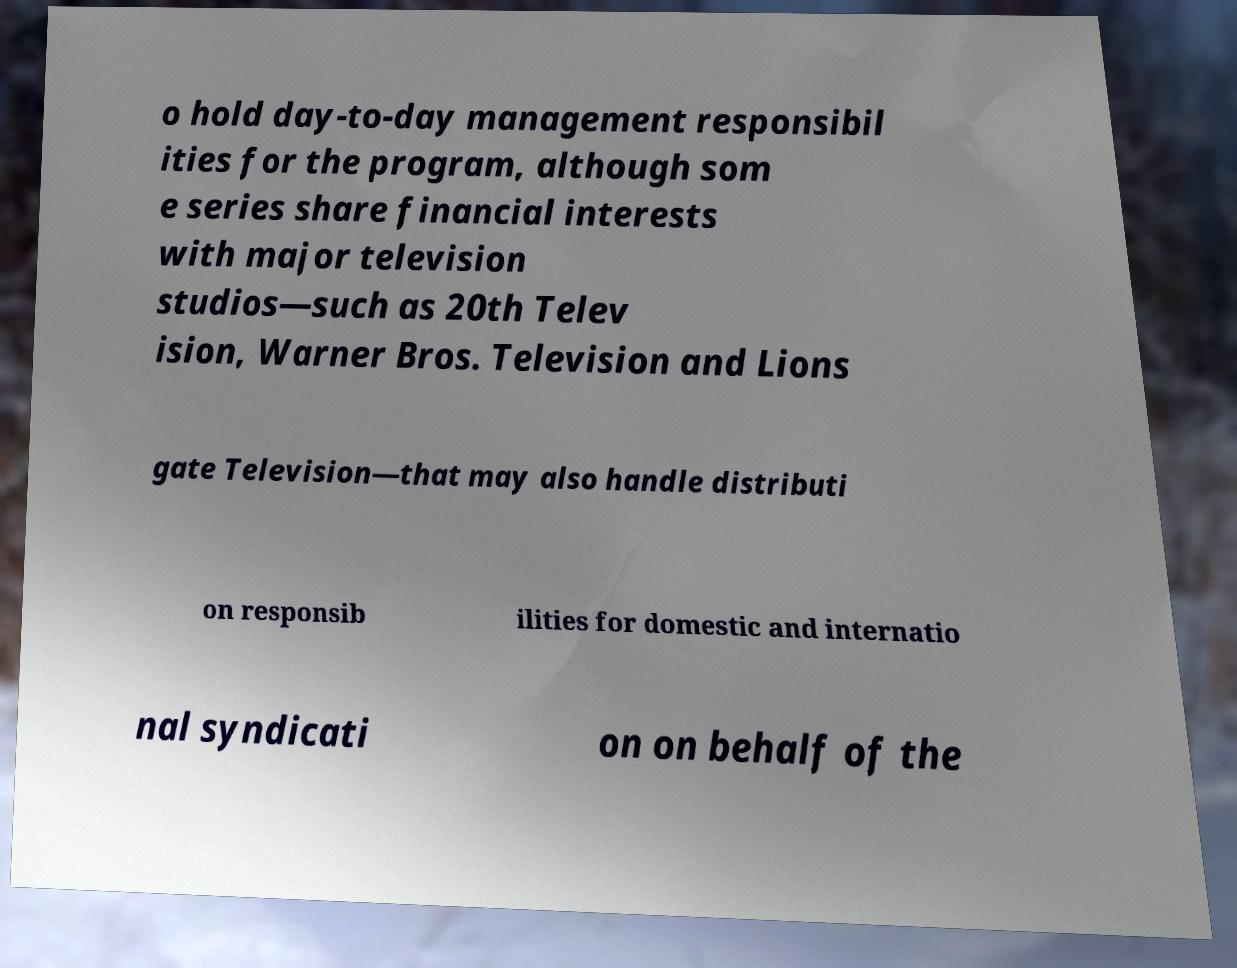Please identify and transcribe the text found in this image. o hold day-to-day management responsibil ities for the program, although som e series share financial interests with major television studios—such as 20th Telev ision, Warner Bros. Television and Lions gate Television—that may also handle distributi on responsib ilities for domestic and internatio nal syndicati on on behalf of the 